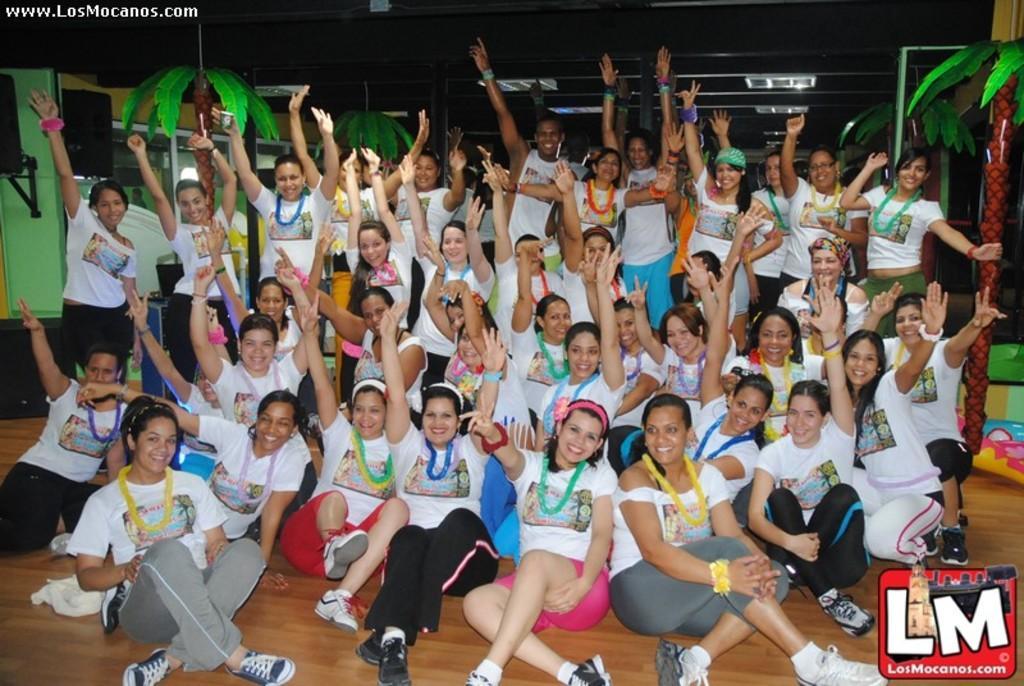Please provide a concise description of this image. In the picture I can see these people wearing white T-shirts are sitting on the wooden floor and smiling and we can see these people wearing white T-shirts are standing. In the background, we can see some decorative items, ceiling lights and speaker boxes. Here we can see the watermark at the top left side of the image and a logo at the bottom right side of the image. 